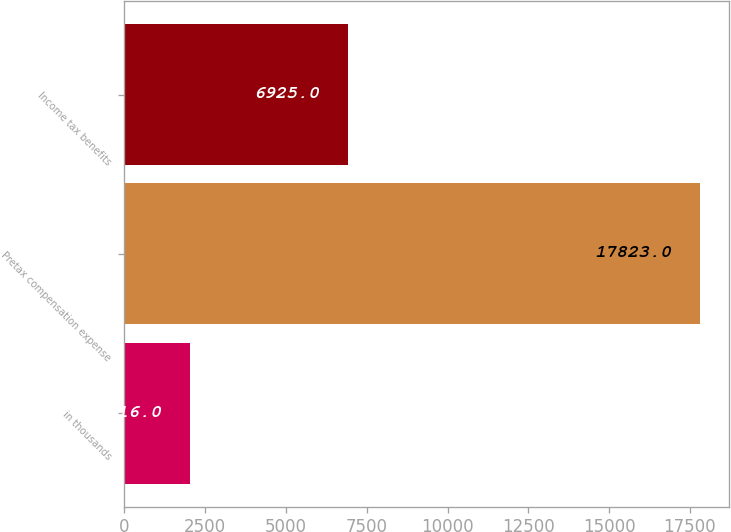Convert chart to OTSL. <chart><loc_0><loc_0><loc_500><loc_500><bar_chart><fcel>in thousands<fcel>Pretax compensation expense<fcel>Income tax benefits<nl><fcel>2016<fcel>17823<fcel>6925<nl></chart> 